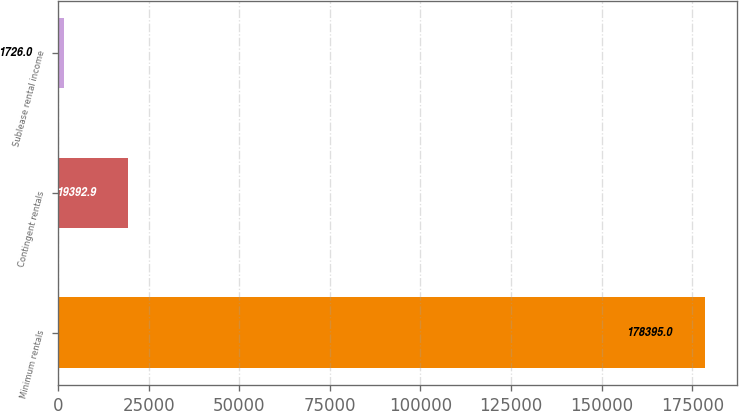Convert chart to OTSL. <chart><loc_0><loc_0><loc_500><loc_500><bar_chart><fcel>Minimum rentals<fcel>Contingent rentals<fcel>Sublease rental income<nl><fcel>178395<fcel>19392.9<fcel>1726<nl></chart> 